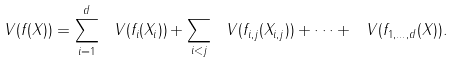Convert formula to latex. <formula><loc_0><loc_0><loc_500><loc_500>\ V ( f ( X ) ) = \sum _ { i = 1 } ^ { d } \ V ( f _ { i } ( X _ { i } ) ) + \sum _ { i < j } \ V ( f _ { i , j } ( X _ { i , j } ) ) + \dots + \ V ( f _ { 1 , \dots , d } ( X ) ) .</formula> 